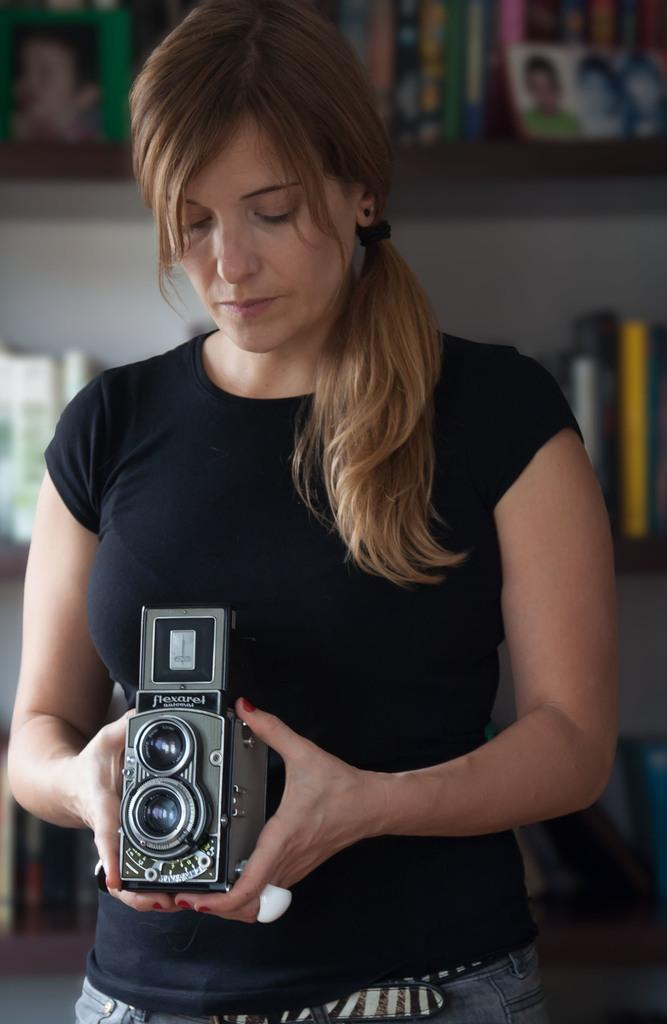What can be seen in the background of the image? There are frames and books arranged in a rack in the background. Can you describe the person in the image? There is a woman in the image, and she is wearing a black shirt. What is the woman holding in her hands? The woman is holding a camera in her hands. What color is the sock on the chair next to the bed in the image? There is no sock, chair, or bed present in the image. 